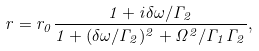Convert formula to latex. <formula><loc_0><loc_0><loc_500><loc_500>r = r _ { 0 } \frac { 1 + i \delta \omega / \Gamma _ { 2 } } { 1 + ( \delta \omega / \Gamma _ { 2 } ) ^ { 2 } + \Omega ^ { 2 } / \Gamma _ { 1 } \Gamma _ { 2 } } ,</formula> 